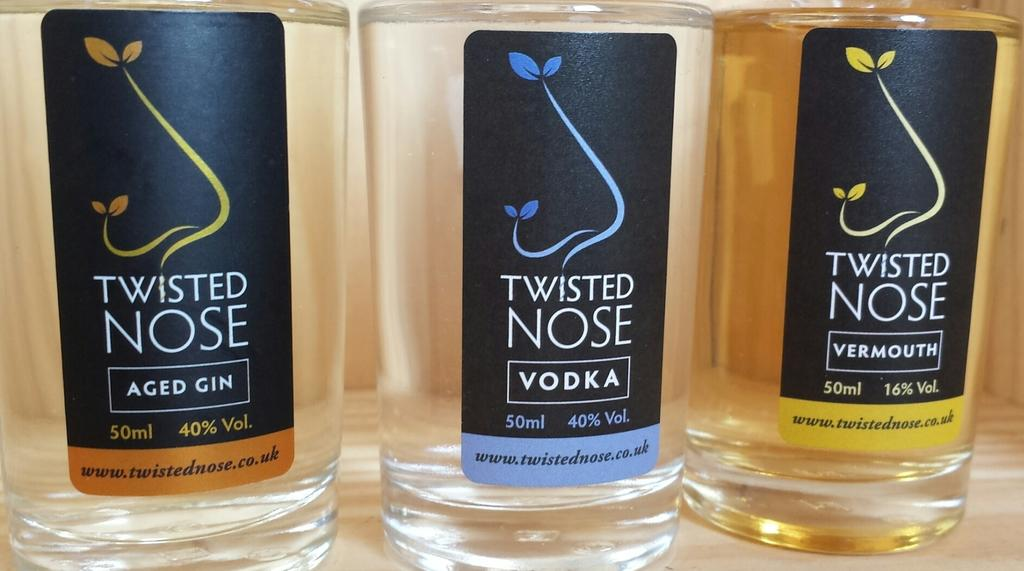Provide a one-sentence caption for the provided image. Three bottles of Twisted Nose alcohol are shown for your viewing pleasure. 